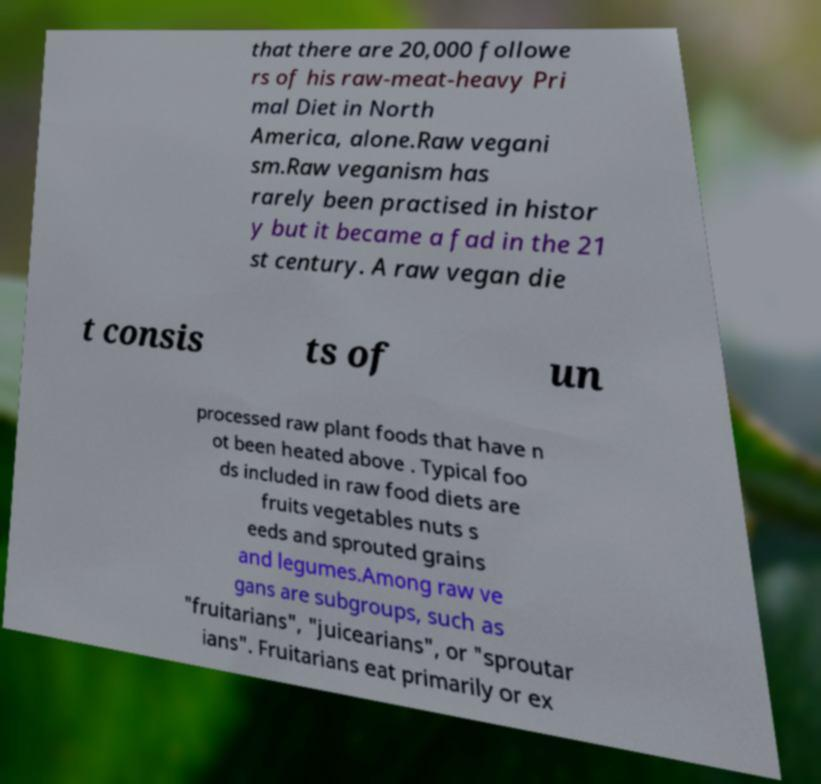Please identify and transcribe the text found in this image. that there are 20,000 followe rs of his raw-meat-heavy Pri mal Diet in North America, alone.Raw vegani sm.Raw veganism has rarely been practised in histor y but it became a fad in the 21 st century. A raw vegan die t consis ts of un processed raw plant foods that have n ot been heated above . Typical foo ds included in raw food diets are fruits vegetables nuts s eeds and sprouted grains and legumes.Among raw ve gans are subgroups, such as "fruitarians", "juicearians", or "sproutar ians". Fruitarians eat primarily or ex 